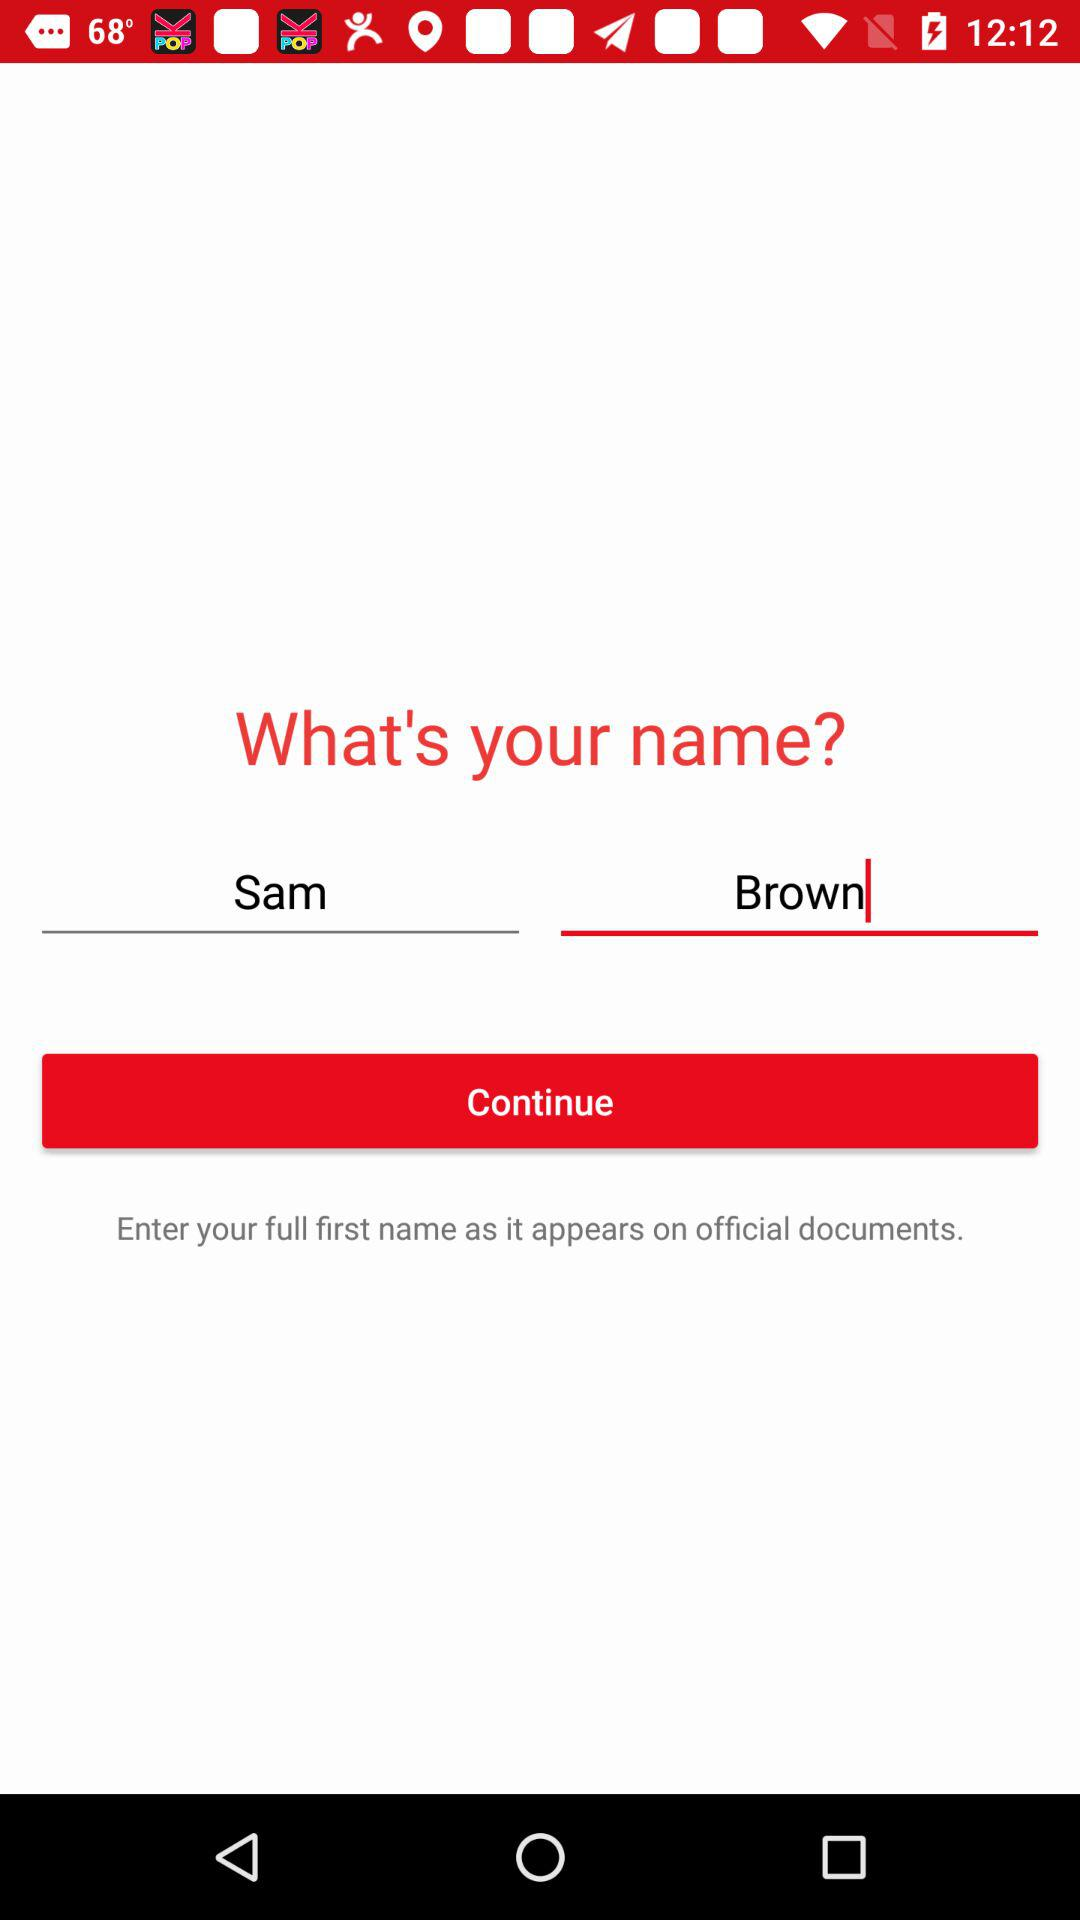What is the user name? The user name is Sam Brown. 